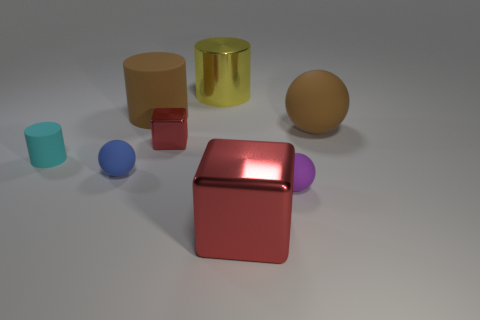Add 1 small purple objects. How many objects exist? 9 Subtract all big brown rubber cylinders. How many cylinders are left? 2 Subtract 0 brown cubes. How many objects are left? 8 Subtract all cubes. How many objects are left? 6 Subtract 2 cubes. How many cubes are left? 0 Subtract all brown spheres. Subtract all cyan cylinders. How many spheres are left? 2 Subtract all red cubes. How many brown spheres are left? 1 Subtract all large cyan blocks. Subtract all large red metal cubes. How many objects are left? 7 Add 2 cyan cylinders. How many cyan cylinders are left? 3 Add 6 big yellow metallic objects. How many big yellow metallic objects exist? 7 